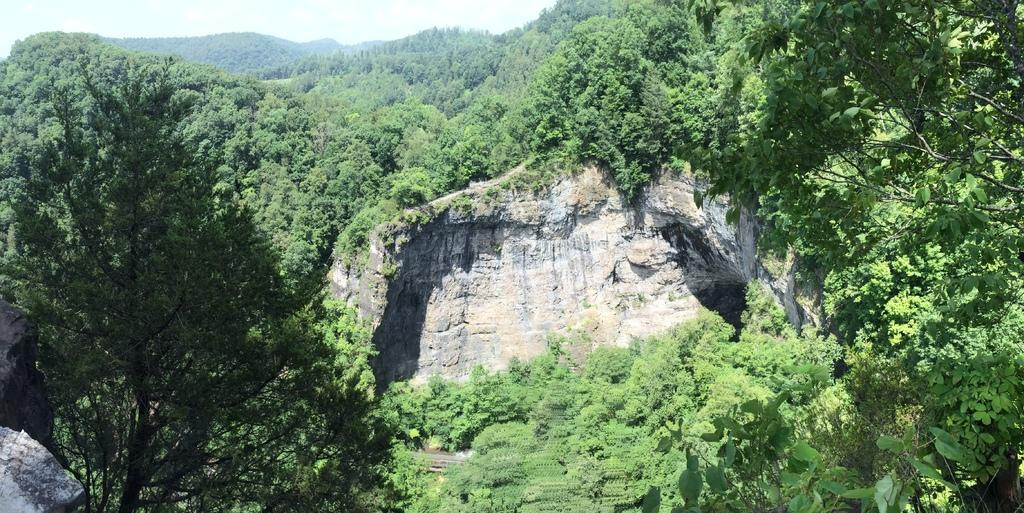What is the main subject in the center of the image? There is a rock in the center of the image. What can be seen in the background of the image? There are trees and the sky visible in the background of the image. What type of brake system is installed on the rock in the image? There is no brake system present on the rock in the image, as it is a natural formation and not a vehicle or machine. 